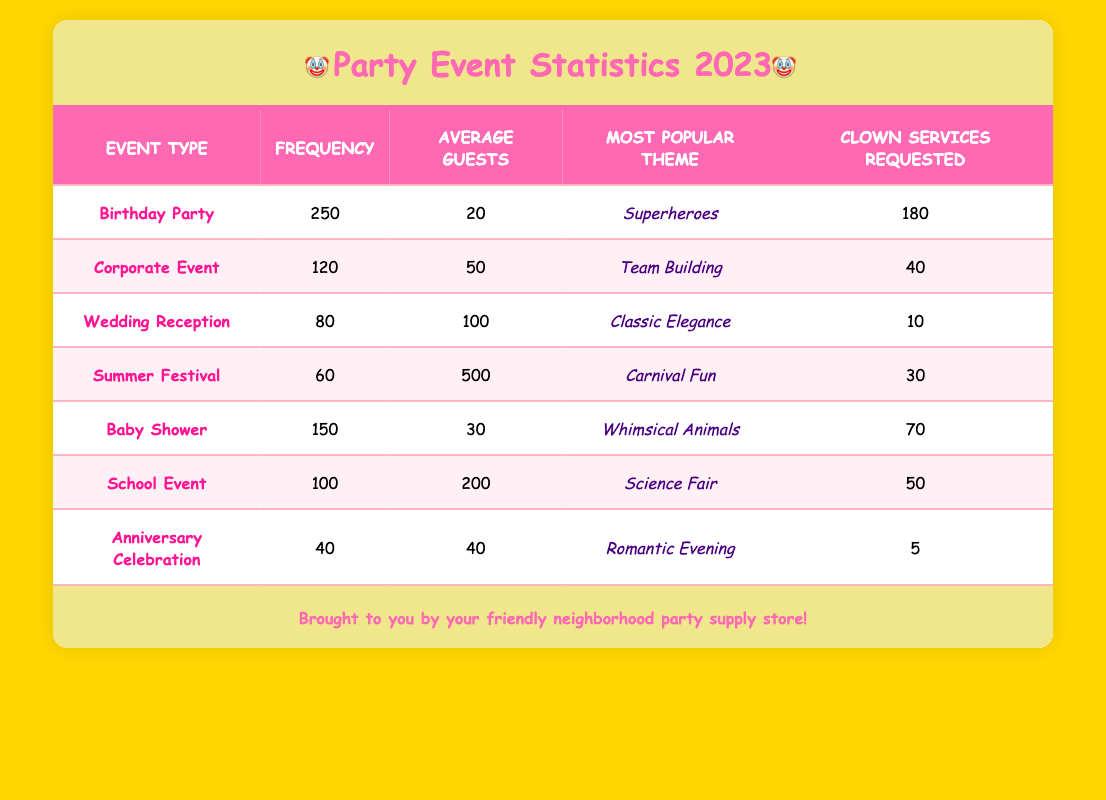What is the most frequent event type? The event type that appears most often in the table is "Birthday Party," with a frequency of 250.
Answer: Birthday Party How many clown services were requested for Corporate Events? According to the table, there were 40 clown services requested for Corporate Events.
Answer: 40 What is the average number of guests for Wedding Receptions? The average number of guests for Wedding Receptions is shown to be 100 in the table.
Answer: 100 Which event type has the highest average number of guests? By comparing the average guests column, the "Summer Festival" has the highest average at 500 guests, as opposed to others.
Answer: Summer Festival How many requested clown services were there in total across all event types? The total number of requested clown services can be calculated by adding the values: 180 (Birthday Party) + 40 (Corporate Event) + 10 (Wedding Reception) + 30 (Summer Festival) + 70 (Baby Shower) + 50 (School Event) + 5 (Anniversary Celebration), which equals 385.
Answer: 385 Is the most popular theme for Baby Showers "Whimsical Animals"? The table confirms that the most popular theme for Baby Showers is indeed "Whimsical Animals."
Answer: Yes What is the difference in frequency between Birthday Parties and Anniversary Celebrations? The frequency for Birthday Parties is 250, while for Anniversary Celebrations it is 40. The difference can be calculated as 250 - 40 = 210.
Answer: 210 For which event type is there the least number of requested clown services? Upon reviewing the table, "Anniversary Celebration" has the least number of requested clown services at just 5.
Answer: Anniversary Celebration What is the average number of guests across "School Events" and "Summer Festivals"? The average number of guests for these two event types can be calculated by adding their average guests: 200 (School Event) + 500 (Summer Festival) = 700, then dividing by 2 gives an average of 350.
Answer: 350 